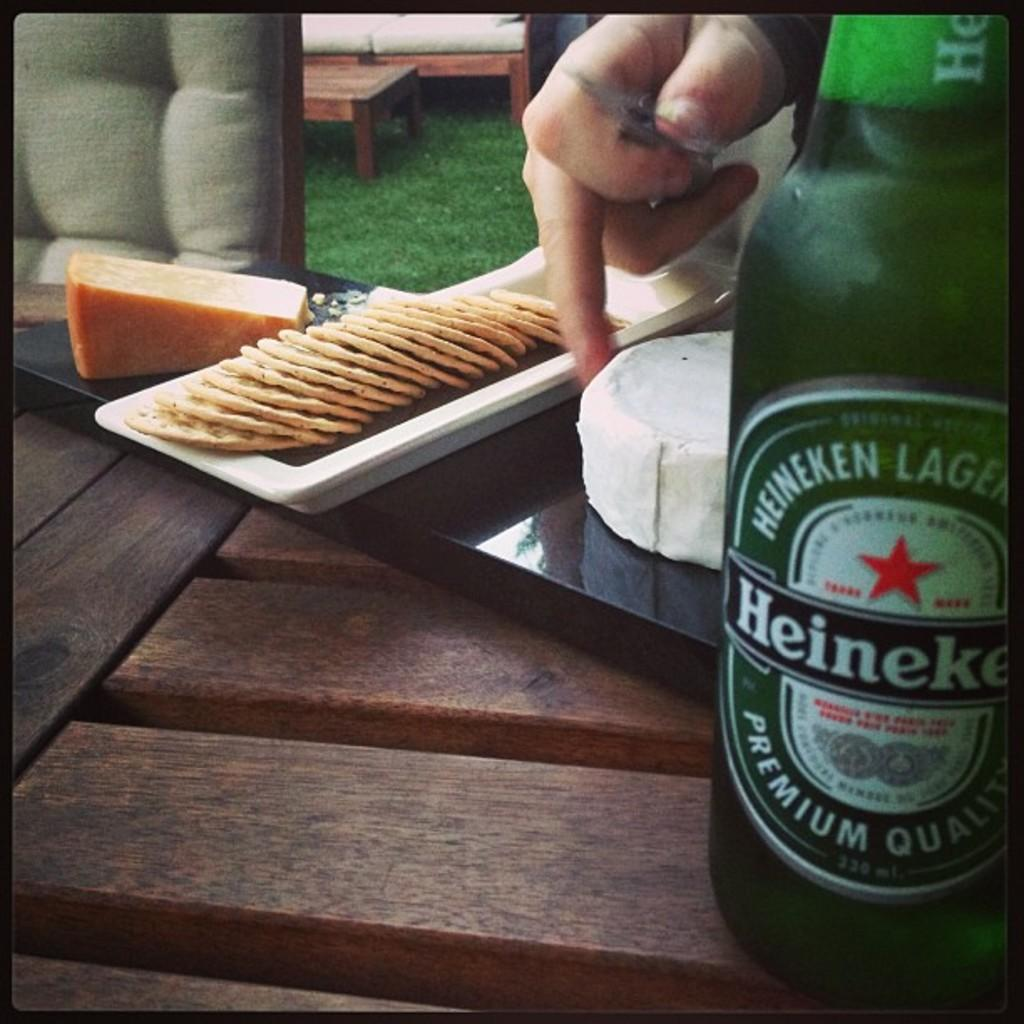<image>
Offer a succinct explanation of the picture presented. A green bottle of Heineken beer sits on a wooden bench. 